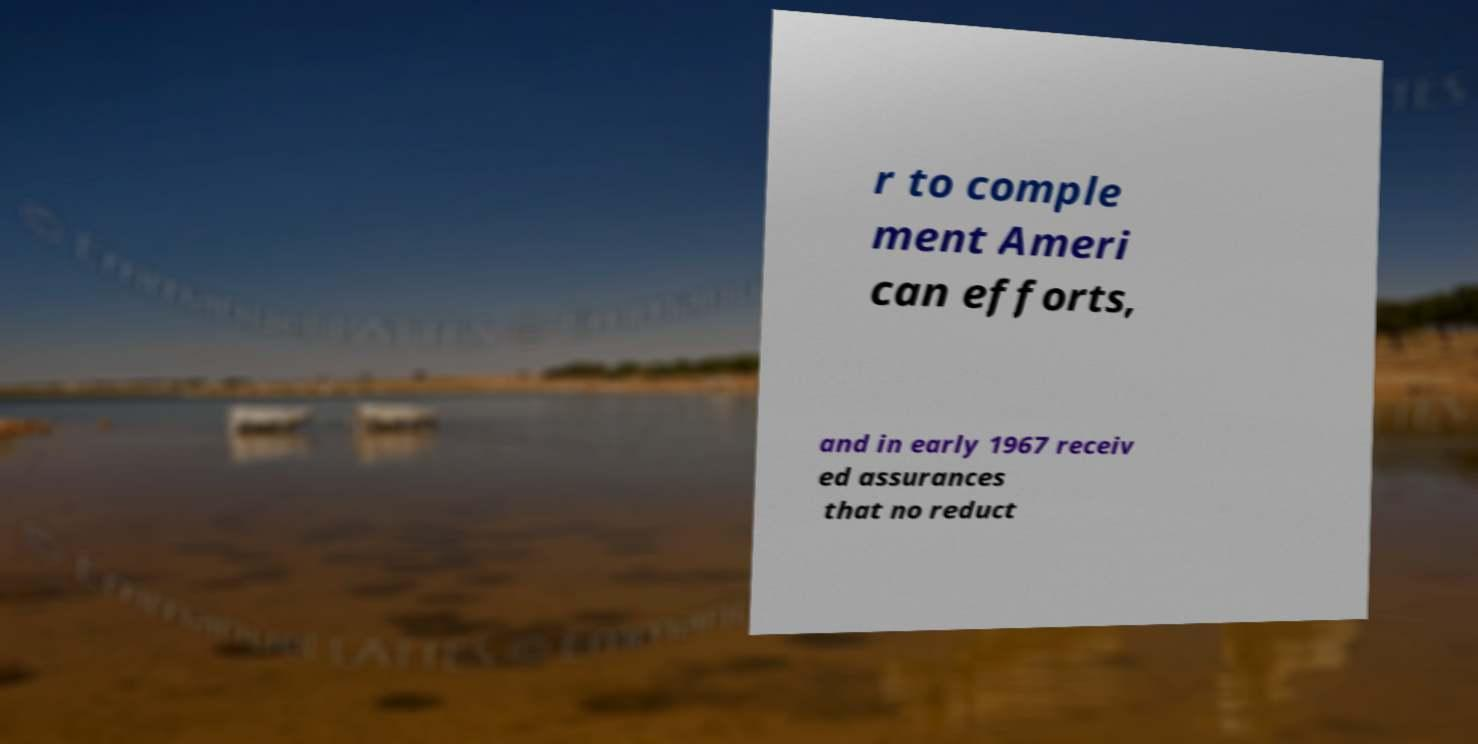Please read and relay the text visible in this image. What does it say? r to comple ment Ameri can efforts, and in early 1967 receiv ed assurances that no reduct 